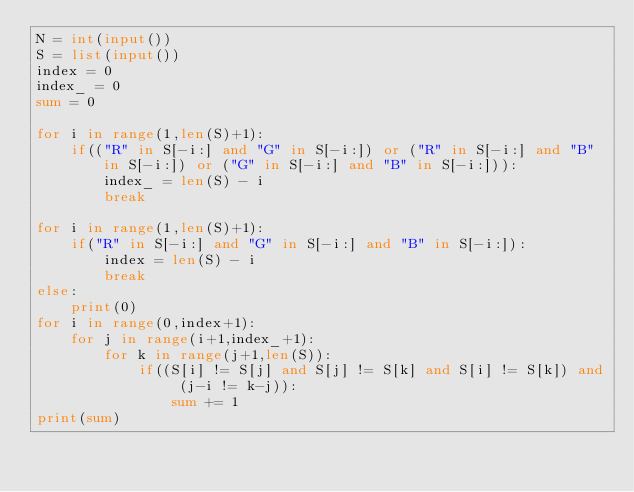Convert code to text. <code><loc_0><loc_0><loc_500><loc_500><_Python_>N = int(input())
S = list(input())
index = 0
index_ = 0
sum = 0

for i in range(1,len(S)+1):
    if(("R" in S[-i:] and "G" in S[-i:]) or ("R" in S[-i:] and "B" in S[-i:]) or ("G" in S[-i:] and "B" in S[-i:])):
        index_ = len(S) - i
        break

for i in range(1,len(S)+1):
    if("R" in S[-i:] and "G" in S[-i:] and "B" in S[-i:]):
        index = len(S) - i
        break
else:
    print(0)
for i in range(0,index+1):
    for j in range(i+1,index_+1):
        for k in range(j+1,len(S)):
            if((S[i] != S[j] and S[j] != S[k] and S[i] != S[k]) and (j-i != k-j)):
                sum += 1
print(sum)
</code> 